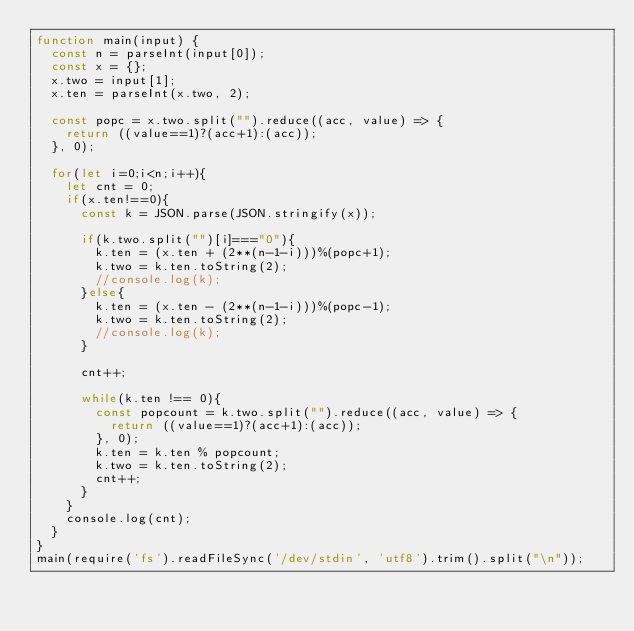<code> <loc_0><loc_0><loc_500><loc_500><_JavaScript_>function main(input) {
  const n = parseInt(input[0]);
  const x = {};
  x.two = input[1];
  x.ten = parseInt(x.two, 2);

  const popc = x.two.split("").reduce((acc, value) => {
    return ((value==1)?(acc+1):(acc));
  }, 0);

  for(let i=0;i<n;i++){
    let cnt = 0;
    if(x.ten!==0){
      const k = JSON.parse(JSON.stringify(x));

      if(k.two.split("")[i]==="0"){
        k.ten = (x.ten + (2**(n-1-i)))%(popc+1);
        k.two = k.ten.toString(2);
        //console.log(k);
      }else{
        k.ten = (x.ten - (2**(n-1-i)))%(popc-1);
        k.two = k.ten.toString(2);
        //console.log(k);
      }

      cnt++;

      while(k.ten !== 0){
        const popcount = k.two.split("").reduce((acc, value) => {
          return ((value==1)?(acc+1):(acc));
        }, 0);
        k.ten = k.ten % popcount;
        k.two = k.ten.toString(2);
        cnt++;
      }
    }
    console.log(cnt);
  }  
}
main(require('fs').readFileSync('/dev/stdin', 'utf8').trim().split("\n"));</code> 